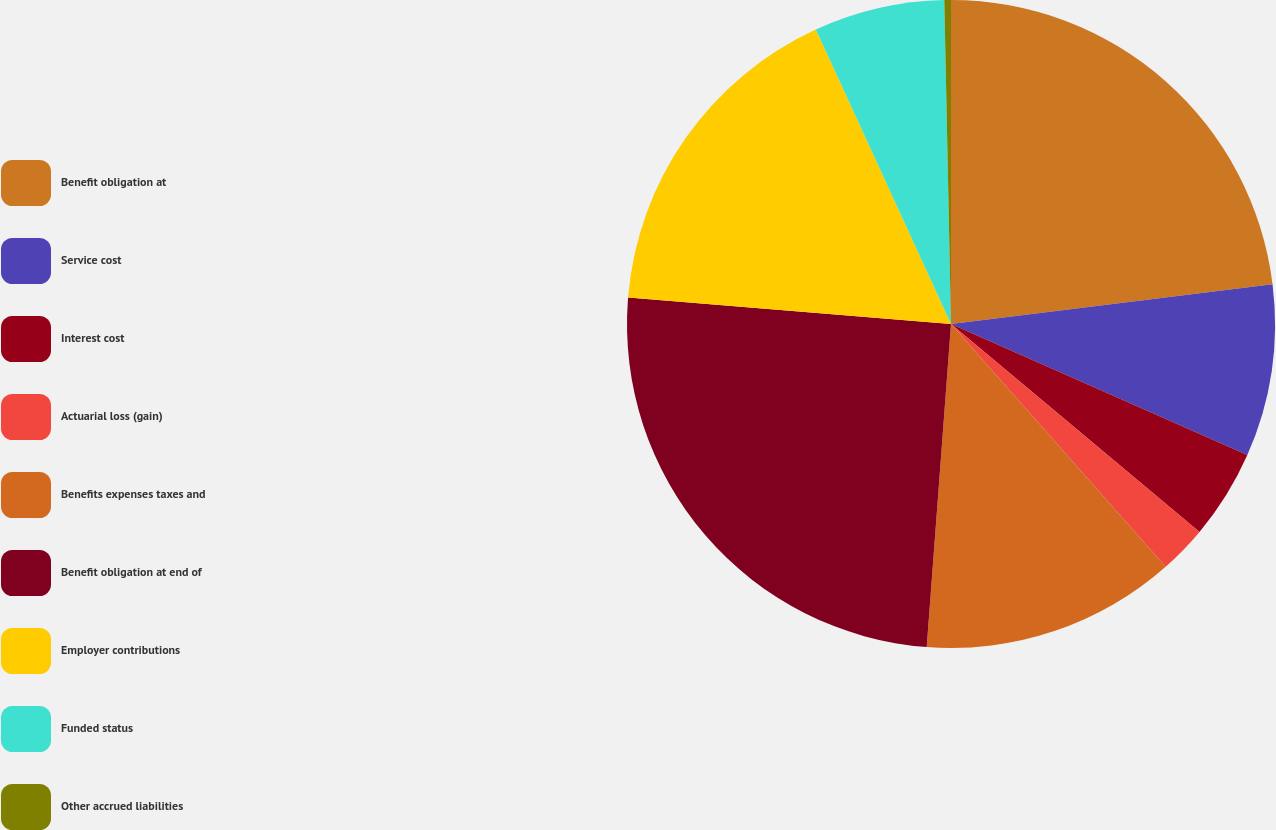Convert chart to OTSL. <chart><loc_0><loc_0><loc_500><loc_500><pie_chart><fcel>Benefit obligation at<fcel>Service cost<fcel>Interest cost<fcel>Actuarial loss (gain)<fcel>Benefits expenses taxes and<fcel>Benefit obligation at end of<fcel>Employer contributions<fcel>Funded status<fcel>Other accrued liabilities<nl><fcel>23.04%<fcel>8.59%<fcel>4.46%<fcel>2.39%<fcel>12.72%<fcel>25.11%<fcel>16.85%<fcel>6.52%<fcel>0.33%<nl></chart> 